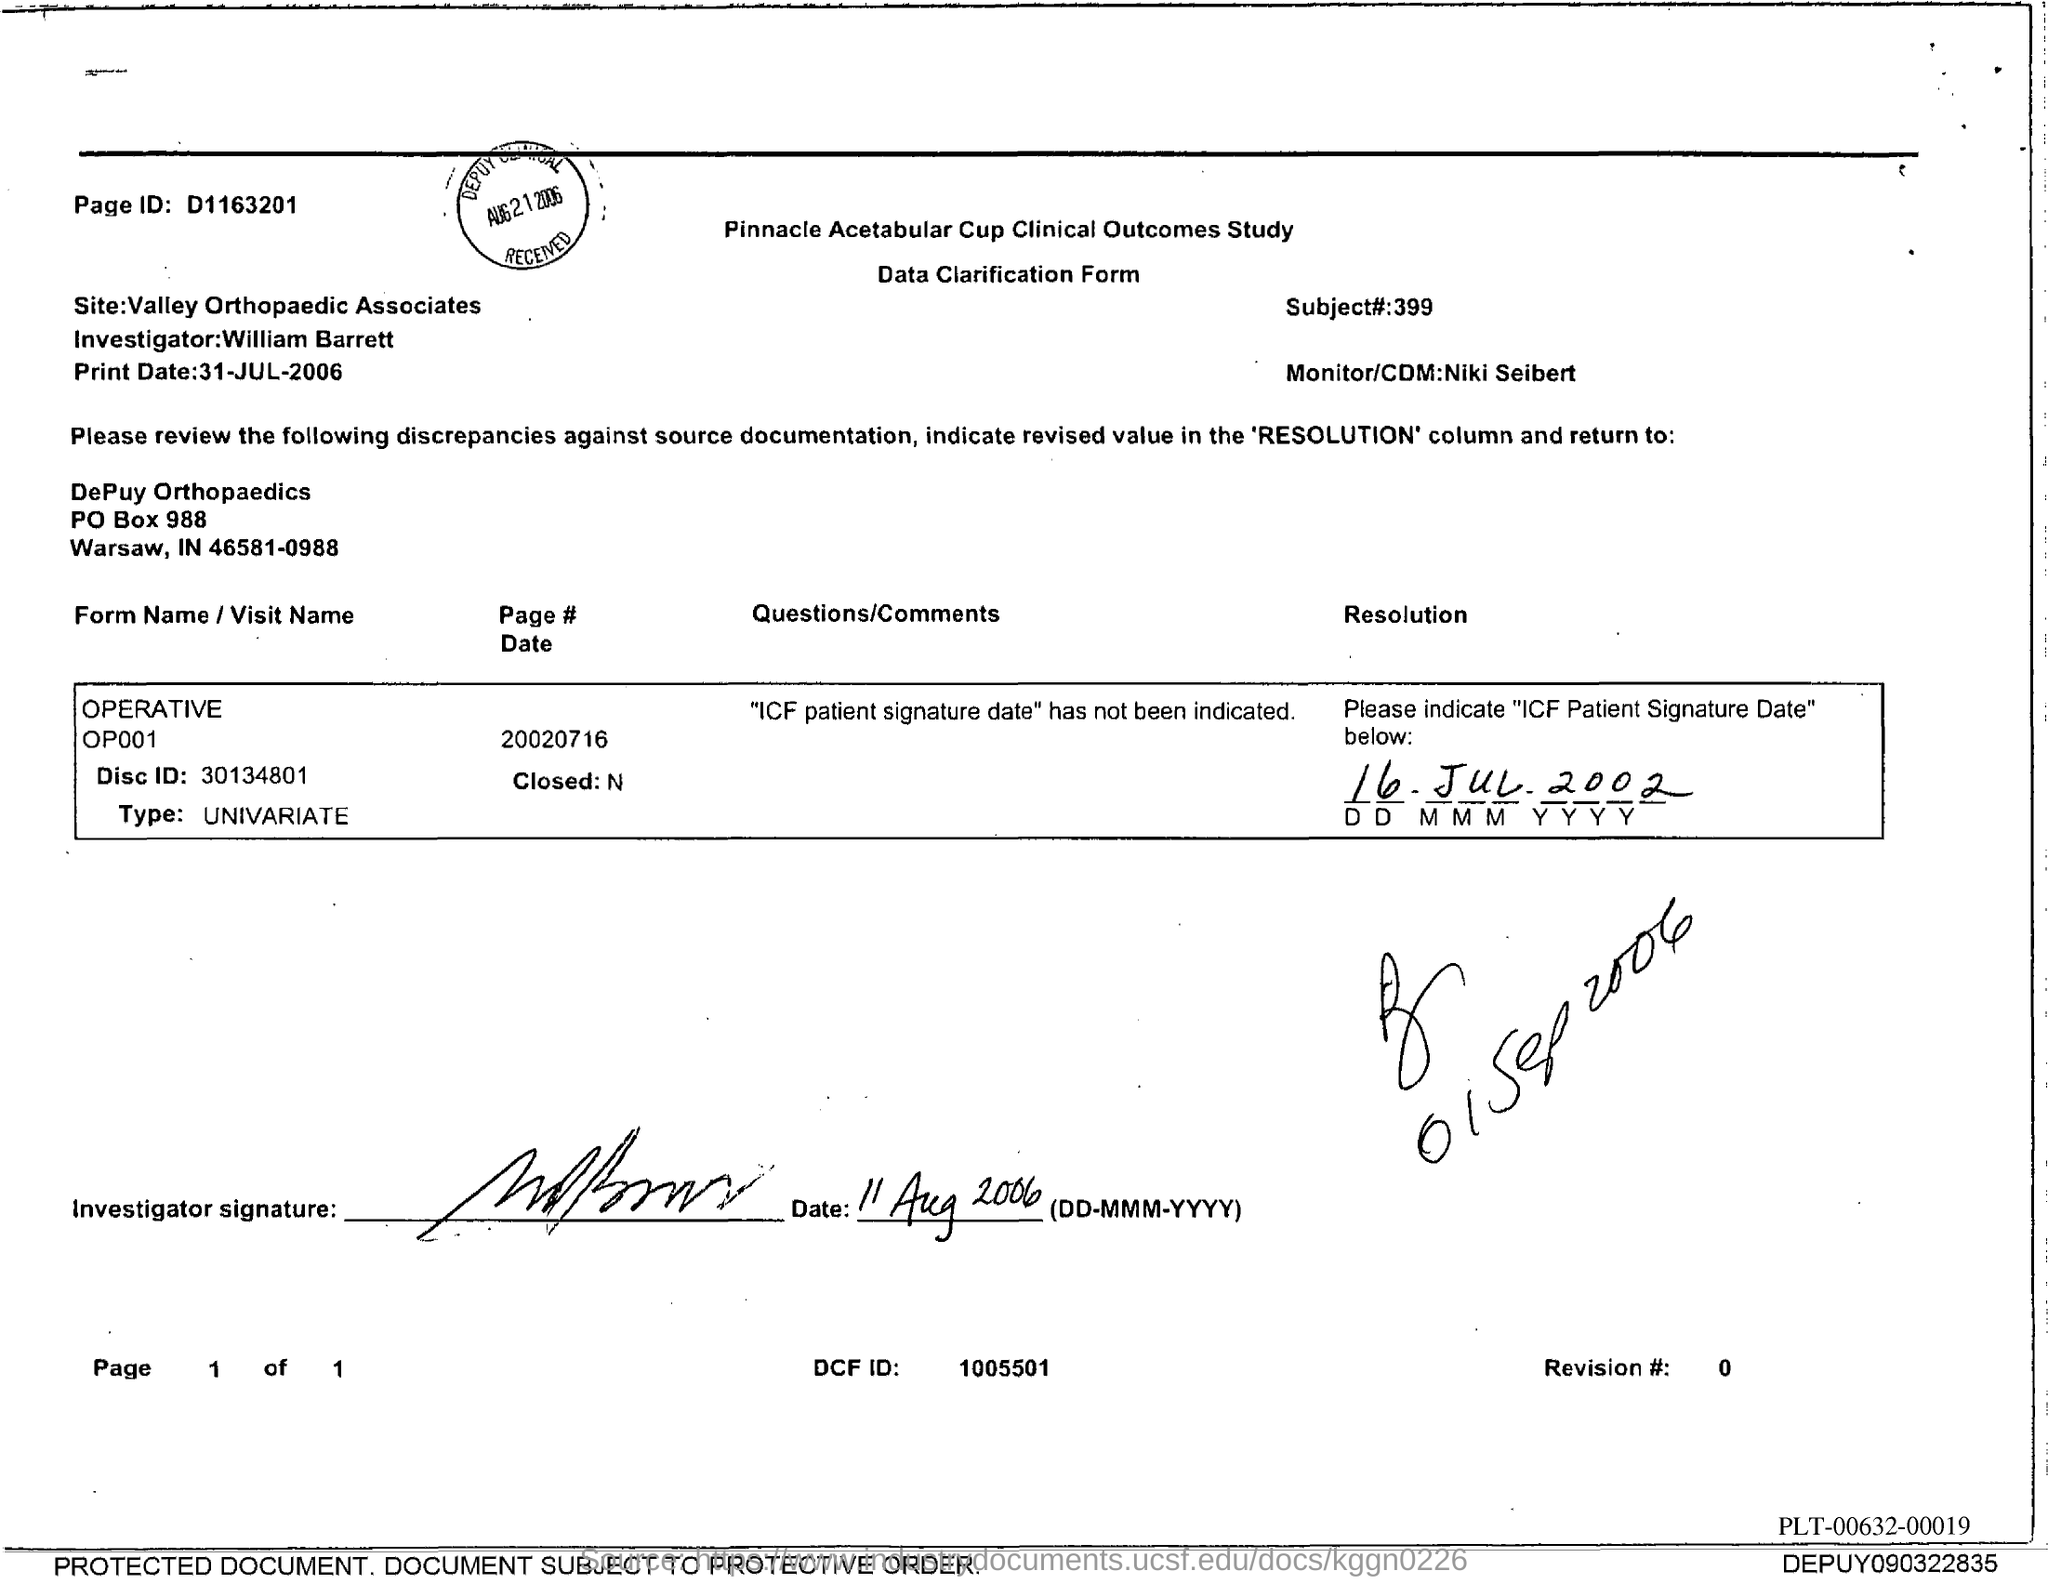What is the Page ID mentioned in the form?
Make the answer very short. D1163201. What is the subject# mentioned in the form?
Your response must be concise. 399. Who is the Investigator mentioned in the form?
Your answer should be compact. William Barrett. What is the print date given in the form?
Make the answer very short. 31-JUL-2006. What is the DCF ID mentioned in the form?
Give a very brief answer. 1005501. Who is the Monitor/CDM as mentioned in the form?
Give a very brief answer. Niki Seibert. 